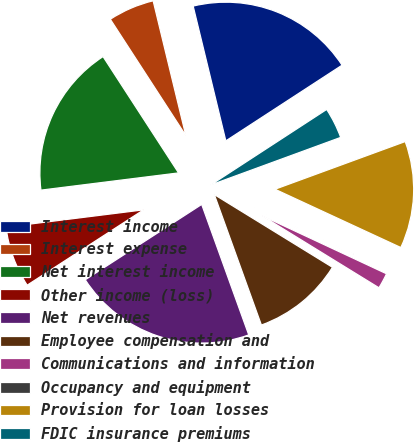Convert chart to OTSL. <chart><loc_0><loc_0><loc_500><loc_500><pie_chart><fcel>Interest income<fcel>Interest expense<fcel>Net interest income<fcel>Other income (loss)<fcel>Net revenues<fcel>Employee compensation and<fcel>Communications and information<fcel>Occupancy and equipment<fcel>Provision for loan losses<fcel>FDIC insurance premiums<nl><fcel>19.6%<fcel>5.38%<fcel>17.82%<fcel>7.16%<fcel>21.37%<fcel>10.71%<fcel>1.83%<fcel>0.05%<fcel>12.49%<fcel>3.6%<nl></chart> 